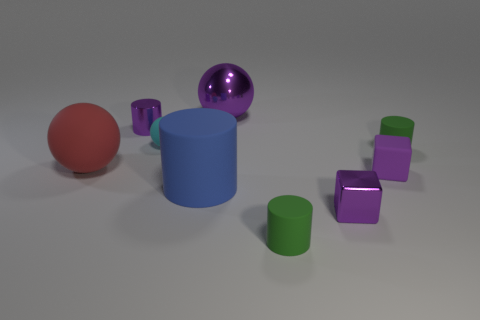What material is the tiny purple thing that is on the left side of the purple matte thing and in front of the large red rubber ball?
Make the answer very short. Metal. Does the large metal ball have the same color as the shiny thing on the right side of the large purple shiny ball?
Provide a succinct answer. Yes. There is another purple thing that is the same shape as the purple matte thing; what is its size?
Give a very brief answer. Small. The thing that is behind the tiny ball and to the left of the large shiny object has what shape?
Provide a short and direct response. Cylinder. Is the size of the blue cylinder the same as the red ball left of the tiny purple matte object?
Offer a terse response. Yes. The shiny object that is the same shape as the small cyan matte object is what color?
Offer a terse response. Purple. Do the metallic thing that is in front of the purple cylinder and the matte cylinder that is left of the purple sphere have the same size?
Offer a terse response. No. Do the small cyan rubber thing and the big metallic thing have the same shape?
Your answer should be compact. Yes. What number of objects are either objects to the right of the small ball or metal objects?
Your answer should be very brief. 7. Is there another purple metallic object of the same shape as the big purple metallic object?
Your answer should be compact. No. 